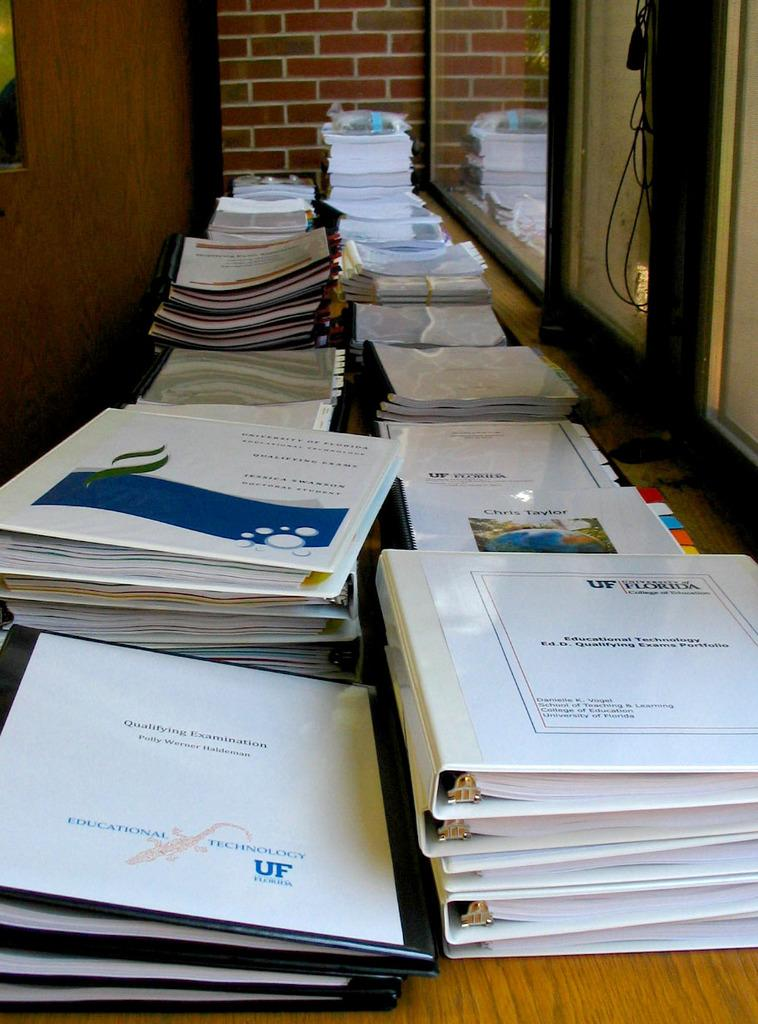<image>
Present a compact description of the photo's key features. Stacks of binders filled with Educational Technology Qualifying Exams. 